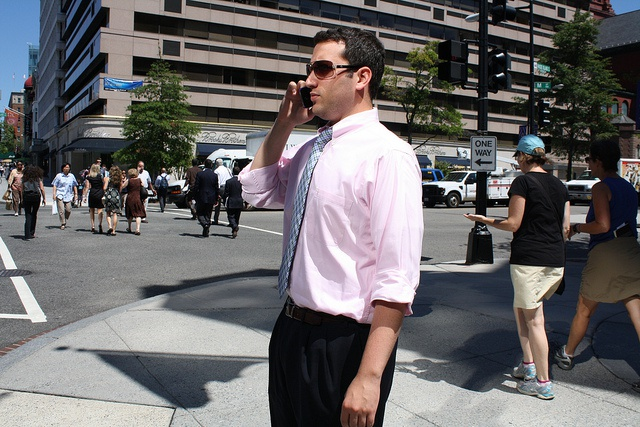Describe the objects in this image and their specific colors. I can see people in gray, lavender, black, pink, and darkgray tones, people in gray, black, lightgray, and darkgray tones, people in gray, black, and maroon tones, people in gray, black, darkgray, and lightgray tones, and truck in gray, black, lightgray, and darkgray tones in this image. 